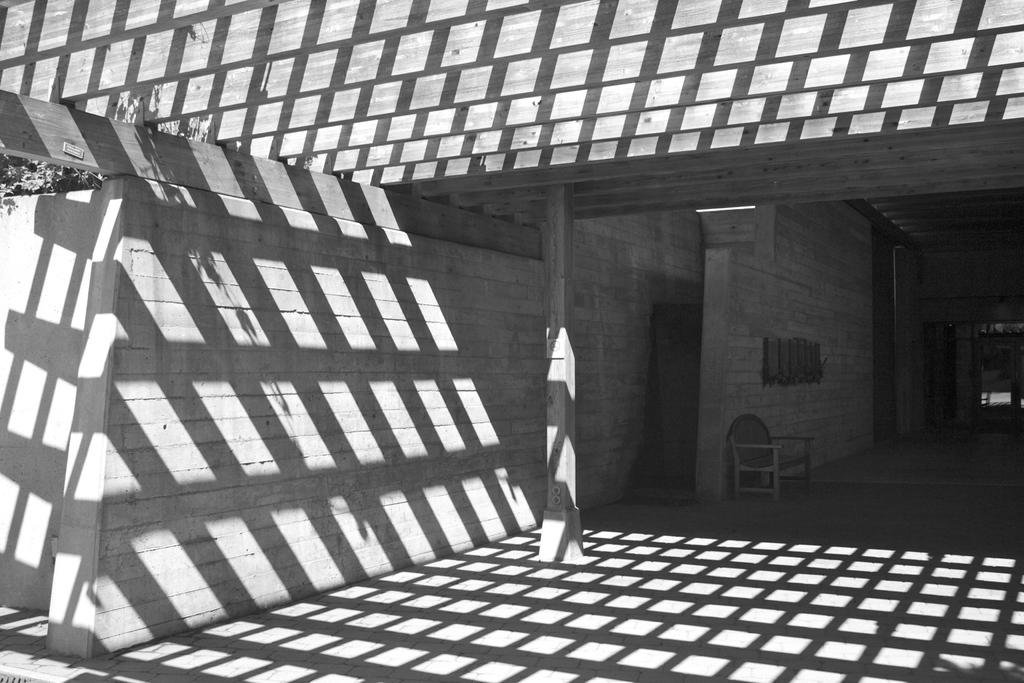What is the color scheme of the image? The image is black and white. What can be seen at the entrance of the house in the image? There is an entrance to a house and a chair in the entrance of the house. What type of hose is being used to water the plants in the image? There are no plants or hoses visible in the image; it only features an entrance to a house and a chair. 